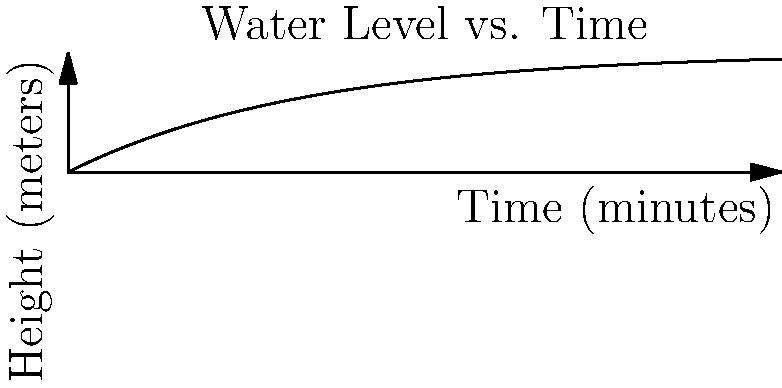A conical water tank with a height of 5 meters and a base radius of 2 meters is being filled with water. The rate at which the water level rises is proportional to the difference between the current height and the tank's full height. If the water level reaches 3 meters after 15 minutes, at what rate (in meters per minute) is the water level rising when the tank is half full? Let's approach this step-by-step:

1) Let $h(t)$ be the height of water at time $t$. We're given that:
   $\frac{dh}{dt} = k(5-h)$, where $k$ is some constant.

2) Solving this differential equation:
   $h(t) = 5(1-e^{-kt})$

3) We're told that $h(15) = 3$. Let's use this to find $k$:
   $3 = 5(1-e^{-15k})$
   $0.4 = e^{-15k}$
   $k = \frac{-\ln(0.4)}{15} \approx 0.0611$

4) Now, we want to find $\frac{dh}{dt}$ when $h = 2.5$ (half full).
   $\frac{dh}{dt} = k(5-h) = 0.0611(5-2.5) = 0.15275$

5) To verify, we can find when the tank is half full:
   $2.5 = 5(1-e^{-0.0611t})$
   $t \approx 11.34$ minutes

6) Plugging this back into our original equation:
   $\frac{dh}{dt} = 0.0611(5-2.5) = 0.15275$

Therefore, when the tank is half full, the water level is rising at approximately 0.15275 meters per minute.
Answer: $0.15275$ meters/minute 